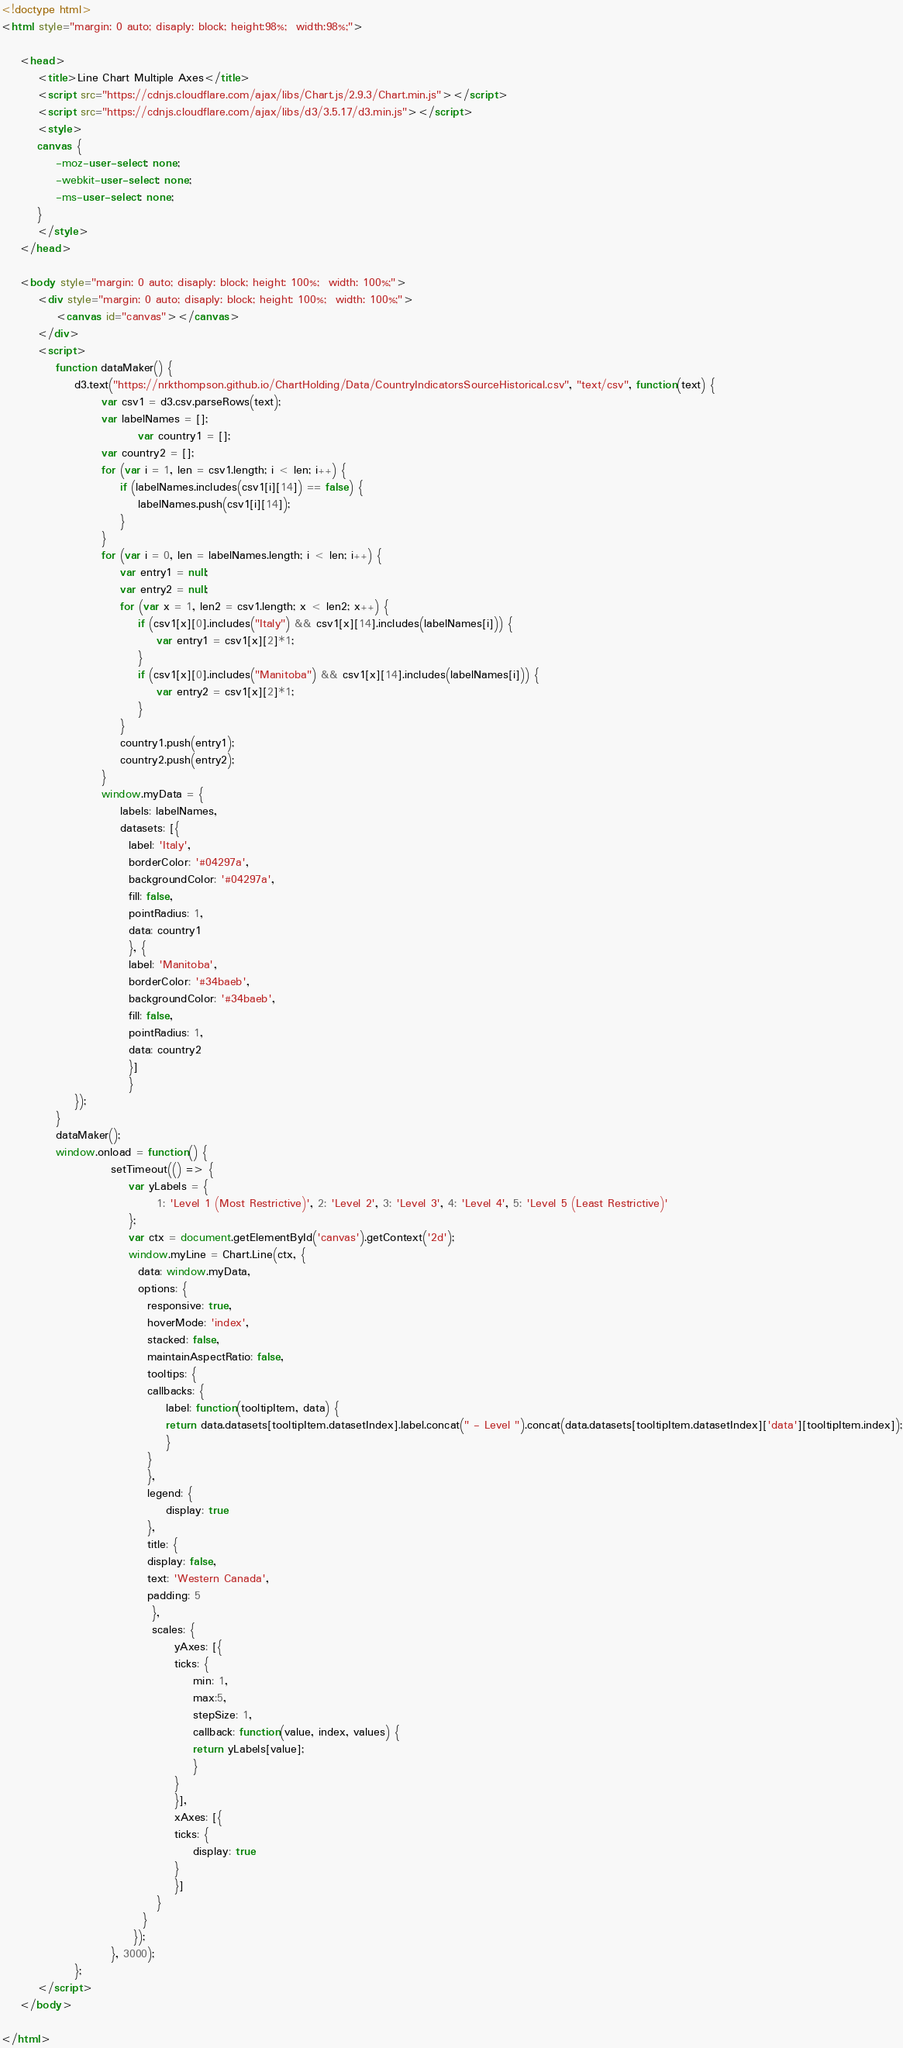Convert code to text. <code><loc_0><loc_0><loc_500><loc_500><_HTML_>
<!doctype html>
<html style="margin: 0 auto; disaply: block; height:98%;  width:98%;">

	<head>
		<title>Line Chart Multiple Axes</title>
		<script src="https://cdnjs.cloudflare.com/ajax/libs/Chart.js/2.9.3/Chart.min.js"></script>
		<script src="https://cdnjs.cloudflare.com/ajax/libs/d3/3.5.17/d3.min.js"></script>
		<style>
		canvas {
			-moz-user-select: none;
			-webkit-user-select: none;
			-ms-user-select: none;
		}
		</style>
	</head>

	<body style="margin: 0 auto; disaply: block; height: 100%;  width: 100%;">
		<div style="margin: 0 auto; disaply: block; height: 100%;  width: 100%;">
			<canvas id="canvas"></canvas>
		</div>
		<script>
			function dataMaker() {
				d3.text("https://nrkthompson.github.io/ChartHolding/Data/CountryIndicatorsSourceHistorical.csv", "text/csv", function(text) {
					  var csv1 = d3.csv.parseRows(text);
					  var labelNames = [];
            				  var country1 = [];
					  var country2 = [];
					  for (var i = 1, len = csv1.length; i < len; i++) {
						  if (labelNames.includes(csv1[i][14]) == false) {
							  labelNames.push(csv1[i][14]);
						  }
					  }
					  for (var i = 0, len = labelNames.length; i < len; i++) {
						  var entry1 = null;
						  var entry2 = null;
						  for (var x = 1, len2 = csv1.length; x < len2; x++) {
							  if (csv1[x][0].includes("Italy") && csv1[x][14].includes(labelNames[i])) {
								  var entry1 = csv1[x][2]*1;
							  }
							  if (csv1[x][0].includes("Manitoba") && csv1[x][14].includes(labelNames[i])) {
								  var entry2 = csv1[x][2]*1;
							  }
						  }
						  country1.push(entry1);
						  country2.push(entry2);
					  }
					  window.myData = {
						  labels: labelNames,
						  datasets: [{
						    label: 'Italy',
						    borderColor: '#04297a',
						    backgroundColor: '#04297a',
						    fill: false,
						    pointRadius: 1,
						    data: country1
						    }, {
						    label: 'Manitoba',
						    borderColor: '#34baeb',
						    backgroundColor: '#34baeb',
						    fill: false,
						    pointRadius: 1,
						    data: country2
						    }]
						    }  
				});
			}
			dataMaker();
			window.onload = function() {
						setTimeout(() => { 
							var yLabels = {
							      1: 'Level 1 (Most Restrictive)', 2: 'Level 2', 3: 'Level 3', 4: 'Level 4', 5: 'Level 5 (Least Restrictive)'
							};
							var ctx = document.getElementById('canvas').getContext('2d');
							window.myLine = Chart.Line(ctx, {
							  data: window.myData,
							  options: {
							    responsive: true,
							    hoverMode: 'index',
							    stacked: false,
							    maintainAspectRatio: false,
							    tooltips: {
								callbacks: {
								    label: function(tooltipItem, data) {
									return data.datasets[tooltipItem.datasetIndex].label.concat(" - Level ").concat(data.datasets[tooltipItem.datasetIndex]['data'][tooltipItem.index]);
								    }
								}
							    },
							    legend: {
								    display: true
							    },
							    title: {
								display: false,
								text: 'Western Canada',
								padding: 5
							     },
							     scales: {
								      yAxes: [{
									  ticks: {
									      min: 1,
									      max:5,
									      stepSize: 1,
									      callback: function(value, index, values) {
										  return yLabels[value];
									      }
									  }
								      }],
								      xAxes: [{
									  ticks: {
									      display: true
									  }
								      }]
								  }
							   }
							 });
						}, 3000);
				};
		</script>
	</body>

</html></code> 